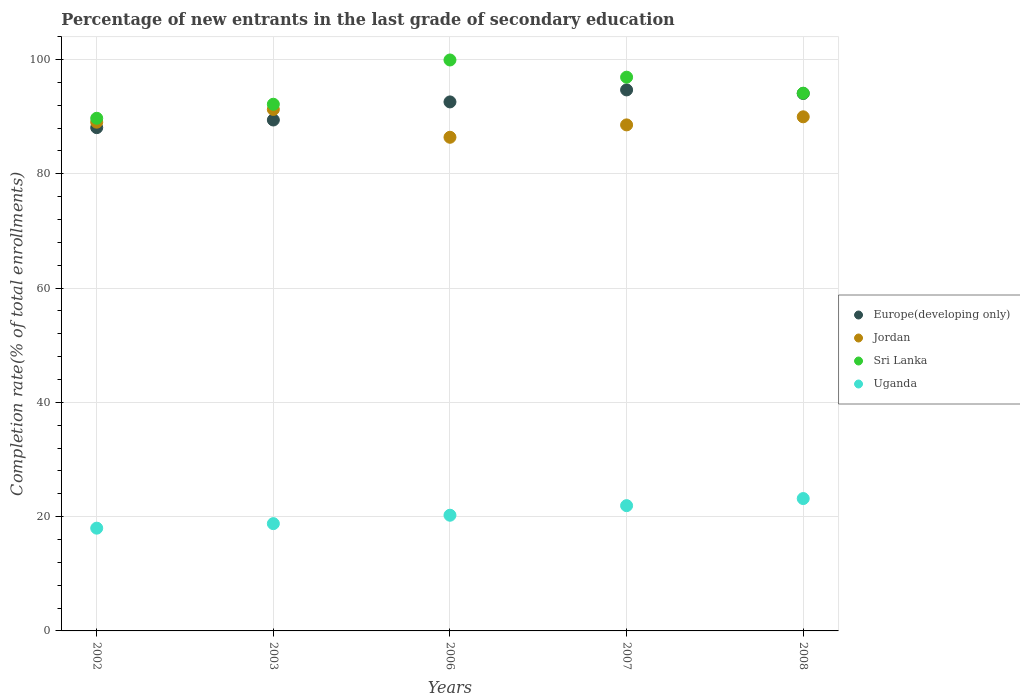What is the percentage of new entrants in Uganda in 2002?
Provide a short and direct response. 17.98. Across all years, what is the maximum percentage of new entrants in Sri Lanka?
Ensure brevity in your answer.  99.91. Across all years, what is the minimum percentage of new entrants in Sri Lanka?
Your response must be concise. 89.71. In which year was the percentage of new entrants in Jordan maximum?
Offer a terse response. 2003. In which year was the percentage of new entrants in Europe(developing only) minimum?
Provide a succinct answer. 2002. What is the total percentage of new entrants in Jordan in the graph?
Your response must be concise. 445.19. What is the difference between the percentage of new entrants in Jordan in 2003 and that in 2008?
Offer a very short reply. 1.29. What is the difference between the percentage of new entrants in Sri Lanka in 2006 and the percentage of new entrants in Europe(developing only) in 2008?
Provide a succinct answer. 5.86. What is the average percentage of new entrants in Uganda per year?
Give a very brief answer. 20.42. In the year 2007, what is the difference between the percentage of new entrants in Sri Lanka and percentage of new entrants in Jordan?
Provide a short and direct response. 8.35. What is the ratio of the percentage of new entrants in Sri Lanka in 2003 to that in 2007?
Your response must be concise. 0.95. What is the difference between the highest and the second highest percentage of new entrants in Jordan?
Your answer should be compact. 1.29. What is the difference between the highest and the lowest percentage of new entrants in Sri Lanka?
Give a very brief answer. 10.2. Is it the case that in every year, the sum of the percentage of new entrants in Jordan and percentage of new entrants in Europe(developing only)  is greater than the sum of percentage of new entrants in Sri Lanka and percentage of new entrants in Uganda?
Your answer should be very brief. No. Does the percentage of new entrants in Europe(developing only) monotonically increase over the years?
Offer a very short reply. No. Is the percentage of new entrants in Europe(developing only) strictly greater than the percentage of new entrants in Uganda over the years?
Offer a terse response. Yes. Are the values on the major ticks of Y-axis written in scientific E-notation?
Provide a short and direct response. No. Does the graph contain any zero values?
Keep it short and to the point. No. What is the title of the graph?
Ensure brevity in your answer.  Percentage of new entrants in the last grade of secondary education. Does "Serbia" appear as one of the legend labels in the graph?
Keep it short and to the point. No. What is the label or title of the Y-axis?
Your response must be concise. Completion rate(% of total enrollments). What is the Completion rate(% of total enrollments) of Europe(developing only) in 2002?
Give a very brief answer. 88.07. What is the Completion rate(% of total enrollments) in Jordan in 2002?
Keep it short and to the point. 89.03. What is the Completion rate(% of total enrollments) of Sri Lanka in 2002?
Offer a very short reply. 89.71. What is the Completion rate(% of total enrollments) of Uganda in 2002?
Offer a very short reply. 17.98. What is the Completion rate(% of total enrollments) in Europe(developing only) in 2003?
Keep it short and to the point. 89.41. What is the Completion rate(% of total enrollments) in Jordan in 2003?
Provide a succinct answer. 91.26. What is the Completion rate(% of total enrollments) in Sri Lanka in 2003?
Offer a very short reply. 92.17. What is the Completion rate(% of total enrollments) in Uganda in 2003?
Make the answer very short. 18.78. What is the Completion rate(% of total enrollments) in Europe(developing only) in 2006?
Provide a succinct answer. 92.58. What is the Completion rate(% of total enrollments) of Jordan in 2006?
Offer a very short reply. 86.39. What is the Completion rate(% of total enrollments) of Sri Lanka in 2006?
Offer a terse response. 99.91. What is the Completion rate(% of total enrollments) of Uganda in 2006?
Give a very brief answer. 20.25. What is the Completion rate(% of total enrollments) of Europe(developing only) in 2007?
Give a very brief answer. 94.68. What is the Completion rate(% of total enrollments) in Jordan in 2007?
Give a very brief answer. 88.55. What is the Completion rate(% of total enrollments) of Sri Lanka in 2007?
Give a very brief answer. 96.9. What is the Completion rate(% of total enrollments) in Uganda in 2007?
Ensure brevity in your answer.  21.92. What is the Completion rate(% of total enrollments) of Europe(developing only) in 2008?
Give a very brief answer. 94.05. What is the Completion rate(% of total enrollments) in Jordan in 2008?
Keep it short and to the point. 89.97. What is the Completion rate(% of total enrollments) in Sri Lanka in 2008?
Keep it short and to the point. 94.1. What is the Completion rate(% of total enrollments) of Uganda in 2008?
Provide a succinct answer. 23.16. Across all years, what is the maximum Completion rate(% of total enrollments) in Europe(developing only)?
Ensure brevity in your answer.  94.68. Across all years, what is the maximum Completion rate(% of total enrollments) in Jordan?
Offer a terse response. 91.26. Across all years, what is the maximum Completion rate(% of total enrollments) in Sri Lanka?
Provide a short and direct response. 99.91. Across all years, what is the maximum Completion rate(% of total enrollments) of Uganda?
Offer a terse response. 23.16. Across all years, what is the minimum Completion rate(% of total enrollments) of Europe(developing only)?
Make the answer very short. 88.07. Across all years, what is the minimum Completion rate(% of total enrollments) of Jordan?
Give a very brief answer. 86.39. Across all years, what is the minimum Completion rate(% of total enrollments) of Sri Lanka?
Your response must be concise. 89.71. Across all years, what is the minimum Completion rate(% of total enrollments) of Uganda?
Your response must be concise. 17.98. What is the total Completion rate(% of total enrollments) in Europe(developing only) in the graph?
Provide a succinct answer. 458.78. What is the total Completion rate(% of total enrollments) in Jordan in the graph?
Provide a succinct answer. 445.19. What is the total Completion rate(% of total enrollments) of Sri Lanka in the graph?
Your response must be concise. 472.8. What is the total Completion rate(% of total enrollments) in Uganda in the graph?
Ensure brevity in your answer.  102.09. What is the difference between the Completion rate(% of total enrollments) of Europe(developing only) in 2002 and that in 2003?
Provide a succinct answer. -1.34. What is the difference between the Completion rate(% of total enrollments) in Jordan in 2002 and that in 2003?
Your response must be concise. -2.23. What is the difference between the Completion rate(% of total enrollments) of Sri Lanka in 2002 and that in 2003?
Your answer should be compact. -2.45. What is the difference between the Completion rate(% of total enrollments) in Uganda in 2002 and that in 2003?
Your response must be concise. -0.79. What is the difference between the Completion rate(% of total enrollments) of Europe(developing only) in 2002 and that in 2006?
Make the answer very short. -4.5. What is the difference between the Completion rate(% of total enrollments) in Jordan in 2002 and that in 2006?
Your answer should be compact. 2.64. What is the difference between the Completion rate(% of total enrollments) in Sri Lanka in 2002 and that in 2006?
Your answer should be very brief. -10.2. What is the difference between the Completion rate(% of total enrollments) in Uganda in 2002 and that in 2006?
Your response must be concise. -2.26. What is the difference between the Completion rate(% of total enrollments) of Europe(developing only) in 2002 and that in 2007?
Offer a terse response. -6.61. What is the difference between the Completion rate(% of total enrollments) of Jordan in 2002 and that in 2007?
Make the answer very short. 0.47. What is the difference between the Completion rate(% of total enrollments) in Sri Lanka in 2002 and that in 2007?
Make the answer very short. -7.19. What is the difference between the Completion rate(% of total enrollments) in Uganda in 2002 and that in 2007?
Ensure brevity in your answer.  -3.94. What is the difference between the Completion rate(% of total enrollments) of Europe(developing only) in 2002 and that in 2008?
Your answer should be very brief. -5.98. What is the difference between the Completion rate(% of total enrollments) of Jordan in 2002 and that in 2008?
Provide a short and direct response. -0.94. What is the difference between the Completion rate(% of total enrollments) in Sri Lanka in 2002 and that in 2008?
Give a very brief answer. -4.39. What is the difference between the Completion rate(% of total enrollments) in Uganda in 2002 and that in 2008?
Provide a short and direct response. -5.18. What is the difference between the Completion rate(% of total enrollments) of Europe(developing only) in 2003 and that in 2006?
Keep it short and to the point. -3.16. What is the difference between the Completion rate(% of total enrollments) of Jordan in 2003 and that in 2006?
Offer a very short reply. 4.87. What is the difference between the Completion rate(% of total enrollments) in Sri Lanka in 2003 and that in 2006?
Keep it short and to the point. -7.75. What is the difference between the Completion rate(% of total enrollments) in Uganda in 2003 and that in 2006?
Your answer should be very brief. -1.47. What is the difference between the Completion rate(% of total enrollments) of Europe(developing only) in 2003 and that in 2007?
Your response must be concise. -5.27. What is the difference between the Completion rate(% of total enrollments) of Jordan in 2003 and that in 2007?
Offer a very short reply. 2.7. What is the difference between the Completion rate(% of total enrollments) in Sri Lanka in 2003 and that in 2007?
Give a very brief answer. -4.74. What is the difference between the Completion rate(% of total enrollments) in Uganda in 2003 and that in 2007?
Offer a very short reply. -3.15. What is the difference between the Completion rate(% of total enrollments) in Europe(developing only) in 2003 and that in 2008?
Your answer should be compact. -4.64. What is the difference between the Completion rate(% of total enrollments) of Jordan in 2003 and that in 2008?
Provide a short and direct response. 1.29. What is the difference between the Completion rate(% of total enrollments) of Sri Lanka in 2003 and that in 2008?
Your answer should be very brief. -1.93. What is the difference between the Completion rate(% of total enrollments) of Uganda in 2003 and that in 2008?
Make the answer very short. -4.39. What is the difference between the Completion rate(% of total enrollments) in Europe(developing only) in 2006 and that in 2007?
Offer a very short reply. -2.1. What is the difference between the Completion rate(% of total enrollments) of Jordan in 2006 and that in 2007?
Your answer should be compact. -2.17. What is the difference between the Completion rate(% of total enrollments) in Sri Lanka in 2006 and that in 2007?
Provide a short and direct response. 3.01. What is the difference between the Completion rate(% of total enrollments) of Uganda in 2006 and that in 2007?
Provide a succinct answer. -1.68. What is the difference between the Completion rate(% of total enrollments) in Europe(developing only) in 2006 and that in 2008?
Keep it short and to the point. -1.48. What is the difference between the Completion rate(% of total enrollments) of Jordan in 2006 and that in 2008?
Your response must be concise. -3.58. What is the difference between the Completion rate(% of total enrollments) in Sri Lanka in 2006 and that in 2008?
Provide a succinct answer. 5.81. What is the difference between the Completion rate(% of total enrollments) in Uganda in 2006 and that in 2008?
Your answer should be very brief. -2.92. What is the difference between the Completion rate(% of total enrollments) in Europe(developing only) in 2007 and that in 2008?
Provide a short and direct response. 0.62. What is the difference between the Completion rate(% of total enrollments) in Jordan in 2007 and that in 2008?
Offer a very short reply. -1.41. What is the difference between the Completion rate(% of total enrollments) in Sri Lanka in 2007 and that in 2008?
Give a very brief answer. 2.8. What is the difference between the Completion rate(% of total enrollments) in Uganda in 2007 and that in 2008?
Keep it short and to the point. -1.24. What is the difference between the Completion rate(% of total enrollments) in Europe(developing only) in 2002 and the Completion rate(% of total enrollments) in Jordan in 2003?
Provide a succinct answer. -3.19. What is the difference between the Completion rate(% of total enrollments) in Europe(developing only) in 2002 and the Completion rate(% of total enrollments) in Sri Lanka in 2003?
Provide a succinct answer. -4.1. What is the difference between the Completion rate(% of total enrollments) in Europe(developing only) in 2002 and the Completion rate(% of total enrollments) in Uganda in 2003?
Give a very brief answer. 69.29. What is the difference between the Completion rate(% of total enrollments) in Jordan in 2002 and the Completion rate(% of total enrollments) in Sri Lanka in 2003?
Your answer should be very brief. -3.14. What is the difference between the Completion rate(% of total enrollments) of Jordan in 2002 and the Completion rate(% of total enrollments) of Uganda in 2003?
Offer a very short reply. 70.25. What is the difference between the Completion rate(% of total enrollments) of Sri Lanka in 2002 and the Completion rate(% of total enrollments) of Uganda in 2003?
Ensure brevity in your answer.  70.94. What is the difference between the Completion rate(% of total enrollments) of Europe(developing only) in 2002 and the Completion rate(% of total enrollments) of Jordan in 2006?
Ensure brevity in your answer.  1.68. What is the difference between the Completion rate(% of total enrollments) of Europe(developing only) in 2002 and the Completion rate(% of total enrollments) of Sri Lanka in 2006?
Keep it short and to the point. -11.84. What is the difference between the Completion rate(% of total enrollments) in Europe(developing only) in 2002 and the Completion rate(% of total enrollments) in Uganda in 2006?
Offer a very short reply. 67.82. What is the difference between the Completion rate(% of total enrollments) in Jordan in 2002 and the Completion rate(% of total enrollments) in Sri Lanka in 2006?
Provide a short and direct response. -10.89. What is the difference between the Completion rate(% of total enrollments) of Jordan in 2002 and the Completion rate(% of total enrollments) of Uganda in 2006?
Provide a succinct answer. 68.78. What is the difference between the Completion rate(% of total enrollments) in Sri Lanka in 2002 and the Completion rate(% of total enrollments) in Uganda in 2006?
Your response must be concise. 69.47. What is the difference between the Completion rate(% of total enrollments) in Europe(developing only) in 2002 and the Completion rate(% of total enrollments) in Jordan in 2007?
Give a very brief answer. -0.48. What is the difference between the Completion rate(% of total enrollments) in Europe(developing only) in 2002 and the Completion rate(% of total enrollments) in Sri Lanka in 2007?
Give a very brief answer. -8.83. What is the difference between the Completion rate(% of total enrollments) of Europe(developing only) in 2002 and the Completion rate(% of total enrollments) of Uganda in 2007?
Your answer should be compact. 66.15. What is the difference between the Completion rate(% of total enrollments) of Jordan in 2002 and the Completion rate(% of total enrollments) of Sri Lanka in 2007?
Provide a short and direct response. -7.87. What is the difference between the Completion rate(% of total enrollments) of Jordan in 2002 and the Completion rate(% of total enrollments) of Uganda in 2007?
Offer a terse response. 67.11. What is the difference between the Completion rate(% of total enrollments) of Sri Lanka in 2002 and the Completion rate(% of total enrollments) of Uganda in 2007?
Provide a short and direct response. 67.79. What is the difference between the Completion rate(% of total enrollments) in Europe(developing only) in 2002 and the Completion rate(% of total enrollments) in Jordan in 2008?
Provide a short and direct response. -1.9. What is the difference between the Completion rate(% of total enrollments) in Europe(developing only) in 2002 and the Completion rate(% of total enrollments) in Sri Lanka in 2008?
Offer a very short reply. -6.03. What is the difference between the Completion rate(% of total enrollments) of Europe(developing only) in 2002 and the Completion rate(% of total enrollments) of Uganda in 2008?
Ensure brevity in your answer.  64.91. What is the difference between the Completion rate(% of total enrollments) of Jordan in 2002 and the Completion rate(% of total enrollments) of Sri Lanka in 2008?
Offer a very short reply. -5.07. What is the difference between the Completion rate(% of total enrollments) in Jordan in 2002 and the Completion rate(% of total enrollments) in Uganda in 2008?
Give a very brief answer. 65.86. What is the difference between the Completion rate(% of total enrollments) of Sri Lanka in 2002 and the Completion rate(% of total enrollments) of Uganda in 2008?
Your answer should be very brief. 66.55. What is the difference between the Completion rate(% of total enrollments) of Europe(developing only) in 2003 and the Completion rate(% of total enrollments) of Jordan in 2006?
Keep it short and to the point. 3.02. What is the difference between the Completion rate(% of total enrollments) in Europe(developing only) in 2003 and the Completion rate(% of total enrollments) in Sri Lanka in 2006?
Provide a succinct answer. -10.5. What is the difference between the Completion rate(% of total enrollments) of Europe(developing only) in 2003 and the Completion rate(% of total enrollments) of Uganda in 2006?
Provide a succinct answer. 69.16. What is the difference between the Completion rate(% of total enrollments) of Jordan in 2003 and the Completion rate(% of total enrollments) of Sri Lanka in 2006?
Offer a very short reply. -8.66. What is the difference between the Completion rate(% of total enrollments) of Jordan in 2003 and the Completion rate(% of total enrollments) of Uganda in 2006?
Your response must be concise. 71.01. What is the difference between the Completion rate(% of total enrollments) of Sri Lanka in 2003 and the Completion rate(% of total enrollments) of Uganda in 2006?
Offer a terse response. 71.92. What is the difference between the Completion rate(% of total enrollments) of Europe(developing only) in 2003 and the Completion rate(% of total enrollments) of Jordan in 2007?
Make the answer very short. 0.86. What is the difference between the Completion rate(% of total enrollments) in Europe(developing only) in 2003 and the Completion rate(% of total enrollments) in Sri Lanka in 2007?
Offer a terse response. -7.49. What is the difference between the Completion rate(% of total enrollments) of Europe(developing only) in 2003 and the Completion rate(% of total enrollments) of Uganda in 2007?
Ensure brevity in your answer.  67.49. What is the difference between the Completion rate(% of total enrollments) in Jordan in 2003 and the Completion rate(% of total enrollments) in Sri Lanka in 2007?
Offer a terse response. -5.65. What is the difference between the Completion rate(% of total enrollments) in Jordan in 2003 and the Completion rate(% of total enrollments) in Uganda in 2007?
Ensure brevity in your answer.  69.33. What is the difference between the Completion rate(% of total enrollments) in Sri Lanka in 2003 and the Completion rate(% of total enrollments) in Uganda in 2007?
Offer a very short reply. 70.24. What is the difference between the Completion rate(% of total enrollments) in Europe(developing only) in 2003 and the Completion rate(% of total enrollments) in Jordan in 2008?
Give a very brief answer. -0.56. What is the difference between the Completion rate(% of total enrollments) in Europe(developing only) in 2003 and the Completion rate(% of total enrollments) in Sri Lanka in 2008?
Give a very brief answer. -4.69. What is the difference between the Completion rate(% of total enrollments) in Europe(developing only) in 2003 and the Completion rate(% of total enrollments) in Uganda in 2008?
Keep it short and to the point. 66.25. What is the difference between the Completion rate(% of total enrollments) in Jordan in 2003 and the Completion rate(% of total enrollments) in Sri Lanka in 2008?
Ensure brevity in your answer.  -2.84. What is the difference between the Completion rate(% of total enrollments) in Jordan in 2003 and the Completion rate(% of total enrollments) in Uganda in 2008?
Provide a short and direct response. 68.09. What is the difference between the Completion rate(% of total enrollments) in Sri Lanka in 2003 and the Completion rate(% of total enrollments) in Uganda in 2008?
Your answer should be compact. 69. What is the difference between the Completion rate(% of total enrollments) in Europe(developing only) in 2006 and the Completion rate(% of total enrollments) in Jordan in 2007?
Your answer should be compact. 4.02. What is the difference between the Completion rate(% of total enrollments) in Europe(developing only) in 2006 and the Completion rate(% of total enrollments) in Sri Lanka in 2007?
Your answer should be very brief. -4.33. What is the difference between the Completion rate(% of total enrollments) in Europe(developing only) in 2006 and the Completion rate(% of total enrollments) in Uganda in 2007?
Your answer should be very brief. 70.65. What is the difference between the Completion rate(% of total enrollments) of Jordan in 2006 and the Completion rate(% of total enrollments) of Sri Lanka in 2007?
Your answer should be compact. -10.52. What is the difference between the Completion rate(% of total enrollments) in Jordan in 2006 and the Completion rate(% of total enrollments) in Uganda in 2007?
Offer a terse response. 64.46. What is the difference between the Completion rate(% of total enrollments) of Sri Lanka in 2006 and the Completion rate(% of total enrollments) of Uganda in 2007?
Your response must be concise. 77.99. What is the difference between the Completion rate(% of total enrollments) of Europe(developing only) in 2006 and the Completion rate(% of total enrollments) of Jordan in 2008?
Make the answer very short. 2.61. What is the difference between the Completion rate(% of total enrollments) in Europe(developing only) in 2006 and the Completion rate(% of total enrollments) in Sri Lanka in 2008?
Your response must be concise. -1.53. What is the difference between the Completion rate(% of total enrollments) in Europe(developing only) in 2006 and the Completion rate(% of total enrollments) in Uganda in 2008?
Provide a succinct answer. 69.41. What is the difference between the Completion rate(% of total enrollments) of Jordan in 2006 and the Completion rate(% of total enrollments) of Sri Lanka in 2008?
Your answer should be very brief. -7.71. What is the difference between the Completion rate(% of total enrollments) in Jordan in 2006 and the Completion rate(% of total enrollments) in Uganda in 2008?
Keep it short and to the point. 63.22. What is the difference between the Completion rate(% of total enrollments) in Sri Lanka in 2006 and the Completion rate(% of total enrollments) in Uganda in 2008?
Provide a short and direct response. 76.75. What is the difference between the Completion rate(% of total enrollments) in Europe(developing only) in 2007 and the Completion rate(% of total enrollments) in Jordan in 2008?
Make the answer very short. 4.71. What is the difference between the Completion rate(% of total enrollments) in Europe(developing only) in 2007 and the Completion rate(% of total enrollments) in Sri Lanka in 2008?
Provide a succinct answer. 0.58. What is the difference between the Completion rate(% of total enrollments) in Europe(developing only) in 2007 and the Completion rate(% of total enrollments) in Uganda in 2008?
Offer a very short reply. 71.51. What is the difference between the Completion rate(% of total enrollments) in Jordan in 2007 and the Completion rate(% of total enrollments) in Sri Lanka in 2008?
Provide a succinct answer. -5.55. What is the difference between the Completion rate(% of total enrollments) in Jordan in 2007 and the Completion rate(% of total enrollments) in Uganda in 2008?
Offer a terse response. 65.39. What is the difference between the Completion rate(% of total enrollments) of Sri Lanka in 2007 and the Completion rate(% of total enrollments) of Uganda in 2008?
Offer a terse response. 73.74. What is the average Completion rate(% of total enrollments) in Europe(developing only) per year?
Your answer should be compact. 91.76. What is the average Completion rate(% of total enrollments) of Jordan per year?
Your response must be concise. 89.04. What is the average Completion rate(% of total enrollments) in Sri Lanka per year?
Your response must be concise. 94.56. What is the average Completion rate(% of total enrollments) of Uganda per year?
Offer a very short reply. 20.42. In the year 2002, what is the difference between the Completion rate(% of total enrollments) in Europe(developing only) and Completion rate(% of total enrollments) in Jordan?
Keep it short and to the point. -0.96. In the year 2002, what is the difference between the Completion rate(% of total enrollments) in Europe(developing only) and Completion rate(% of total enrollments) in Sri Lanka?
Offer a terse response. -1.64. In the year 2002, what is the difference between the Completion rate(% of total enrollments) of Europe(developing only) and Completion rate(% of total enrollments) of Uganda?
Make the answer very short. 70.09. In the year 2002, what is the difference between the Completion rate(% of total enrollments) of Jordan and Completion rate(% of total enrollments) of Sri Lanka?
Make the answer very short. -0.69. In the year 2002, what is the difference between the Completion rate(% of total enrollments) in Jordan and Completion rate(% of total enrollments) in Uganda?
Provide a succinct answer. 71.04. In the year 2002, what is the difference between the Completion rate(% of total enrollments) of Sri Lanka and Completion rate(% of total enrollments) of Uganda?
Ensure brevity in your answer.  71.73. In the year 2003, what is the difference between the Completion rate(% of total enrollments) in Europe(developing only) and Completion rate(% of total enrollments) in Jordan?
Provide a succinct answer. -1.85. In the year 2003, what is the difference between the Completion rate(% of total enrollments) of Europe(developing only) and Completion rate(% of total enrollments) of Sri Lanka?
Offer a very short reply. -2.76. In the year 2003, what is the difference between the Completion rate(% of total enrollments) of Europe(developing only) and Completion rate(% of total enrollments) of Uganda?
Provide a succinct answer. 70.63. In the year 2003, what is the difference between the Completion rate(% of total enrollments) in Jordan and Completion rate(% of total enrollments) in Sri Lanka?
Offer a very short reply. -0.91. In the year 2003, what is the difference between the Completion rate(% of total enrollments) in Jordan and Completion rate(% of total enrollments) in Uganda?
Give a very brief answer. 72.48. In the year 2003, what is the difference between the Completion rate(% of total enrollments) of Sri Lanka and Completion rate(% of total enrollments) of Uganda?
Keep it short and to the point. 73.39. In the year 2006, what is the difference between the Completion rate(% of total enrollments) in Europe(developing only) and Completion rate(% of total enrollments) in Jordan?
Provide a short and direct response. 6.19. In the year 2006, what is the difference between the Completion rate(% of total enrollments) in Europe(developing only) and Completion rate(% of total enrollments) in Sri Lanka?
Your response must be concise. -7.34. In the year 2006, what is the difference between the Completion rate(% of total enrollments) of Europe(developing only) and Completion rate(% of total enrollments) of Uganda?
Give a very brief answer. 72.33. In the year 2006, what is the difference between the Completion rate(% of total enrollments) in Jordan and Completion rate(% of total enrollments) in Sri Lanka?
Provide a succinct answer. -13.53. In the year 2006, what is the difference between the Completion rate(% of total enrollments) of Jordan and Completion rate(% of total enrollments) of Uganda?
Give a very brief answer. 66.14. In the year 2006, what is the difference between the Completion rate(% of total enrollments) in Sri Lanka and Completion rate(% of total enrollments) in Uganda?
Keep it short and to the point. 79.67. In the year 2007, what is the difference between the Completion rate(% of total enrollments) of Europe(developing only) and Completion rate(% of total enrollments) of Jordan?
Provide a short and direct response. 6.12. In the year 2007, what is the difference between the Completion rate(% of total enrollments) in Europe(developing only) and Completion rate(% of total enrollments) in Sri Lanka?
Keep it short and to the point. -2.23. In the year 2007, what is the difference between the Completion rate(% of total enrollments) in Europe(developing only) and Completion rate(% of total enrollments) in Uganda?
Offer a terse response. 72.75. In the year 2007, what is the difference between the Completion rate(% of total enrollments) of Jordan and Completion rate(% of total enrollments) of Sri Lanka?
Keep it short and to the point. -8.35. In the year 2007, what is the difference between the Completion rate(% of total enrollments) of Jordan and Completion rate(% of total enrollments) of Uganda?
Ensure brevity in your answer.  66.63. In the year 2007, what is the difference between the Completion rate(% of total enrollments) in Sri Lanka and Completion rate(% of total enrollments) in Uganda?
Make the answer very short. 74.98. In the year 2008, what is the difference between the Completion rate(% of total enrollments) in Europe(developing only) and Completion rate(% of total enrollments) in Jordan?
Make the answer very short. 4.08. In the year 2008, what is the difference between the Completion rate(% of total enrollments) of Europe(developing only) and Completion rate(% of total enrollments) of Sri Lanka?
Your answer should be very brief. -0.05. In the year 2008, what is the difference between the Completion rate(% of total enrollments) of Europe(developing only) and Completion rate(% of total enrollments) of Uganda?
Give a very brief answer. 70.89. In the year 2008, what is the difference between the Completion rate(% of total enrollments) in Jordan and Completion rate(% of total enrollments) in Sri Lanka?
Your response must be concise. -4.13. In the year 2008, what is the difference between the Completion rate(% of total enrollments) in Jordan and Completion rate(% of total enrollments) in Uganda?
Provide a succinct answer. 66.8. In the year 2008, what is the difference between the Completion rate(% of total enrollments) in Sri Lanka and Completion rate(% of total enrollments) in Uganda?
Offer a terse response. 70.94. What is the ratio of the Completion rate(% of total enrollments) of Jordan in 2002 to that in 2003?
Ensure brevity in your answer.  0.98. What is the ratio of the Completion rate(% of total enrollments) of Sri Lanka in 2002 to that in 2003?
Make the answer very short. 0.97. What is the ratio of the Completion rate(% of total enrollments) in Uganda in 2002 to that in 2003?
Keep it short and to the point. 0.96. What is the ratio of the Completion rate(% of total enrollments) in Europe(developing only) in 2002 to that in 2006?
Your answer should be compact. 0.95. What is the ratio of the Completion rate(% of total enrollments) of Jordan in 2002 to that in 2006?
Your answer should be very brief. 1.03. What is the ratio of the Completion rate(% of total enrollments) in Sri Lanka in 2002 to that in 2006?
Your response must be concise. 0.9. What is the ratio of the Completion rate(% of total enrollments) in Uganda in 2002 to that in 2006?
Ensure brevity in your answer.  0.89. What is the ratio of the Completion rate(% of total enrollments) in Europe(developing only) in 2002 to that in 2007?
Your answer should be very brief. 0.93. What is the ratio of the Completion rate(% of total enrollments) in Sri Lanka in 2002 to that in 2007?
Provide a short and direct response. 0.93. What is the ratio of the Completion rate(% of total enrollments) in Uganda in 2002 to that in 2007?
Give a very brief answer. 0.82. What is the ratio of the Completion rate(% of total enrollments) in Europe(developing only) in 2002 to that in 2008?
Give a very brief answer. 0.94. What is the ratio of the Completion rate(% of total enrollments) of Jordan in 2002 to that in 2008?
Give a very brief answer. 0.99. What is the ratio of the Completion rate(% of total enrollments) of Sri Lanka in 2002 to that in 2008?
Offer a terse response. 0.95. What is the ratio of the Completion rate(% of total enrollments) of Uganda in 2002 to that in 2008?
Keep it short and to the point. 0.78. What is the ratio of the Completion rate(% of total enrollments) in Europe(developing only) in 2003 to that in 2006?
Offer a terse response. 0.97. What is the ratio of the Completion rate(% of total enrollments) in Jordan in 2003 to that in 2006?
Your answer should be compact. 1.06. What is the ratio of the Completion rate(% of total enrollments) of Sri Lanka in 2003 to that in 2006?
Your answer should be very brief. 0.92. What is the ratio of the Completion rate(% of total enrollments) of Uganda in 2003 to that in 2006?
Ensure brevity in your answer.  0.93. What is the ratio of the Completion rate(% of total enrollments) in Jordan in 2003 to that in 2007?
Provide a short and direct response. 1.03. What is the ratio of the Completion rate(% of total enrollments) in Sri Lanka in 2003 to that in 2007?
Your response must be concise. 0.95. What is the ratio of the Completion rate(% of total enrollments) in Uganda in 2003 to that in 2007?
Provide a succinct answer. 0.86. What is the ratio of the Completion rate(% of total enrollments) of Europe(developing only) in 2003 to that in 2008?
Your response must be concise. 0.95. What is the ratio of the Completion rate(% of total enrollments) in Jordan in 2003 to that in 2008?
Keep it short and to the point. 1.01. What is the ratio of the Completion rate(% of total enrollments) of Sri Lanka in 2003 to that in 2008?
Your answer should be compact. 0.98. What is the ratio of the Completion rate(% of total enrollments) of Uganda in 2003 to that in 2008?
Offer a very short reply. 0.81. What is the ratio of the Completion rate(% of total enrollments) of Europe(developing only) in 2006 to that in 2007?
Provide a short and direct response. 0.98. What is the ratio of the Completion rate(% of total enrollments) of Jordan in 2006 to that in 2007?
Your answer should be compact. 0.98. What is the ratio of the Completion rate(% of total enrollments) in Sri Lanka in 2006 to that in 2007?
Your answer should be very brief. 1.03. What is the ratio of the Completion rate(% of total enrollments) in Uganda in 2006 to that in 2007?
Offer a very short reply. 0.92. What is the ratio of the Completion rate(% of total enrollments) in Europe(developing only) in 2006 to that in 2008?
Provide a succinct answer. 0.98. What is the ratio of the Completion rate(% of total enrollments) of Jordan in 2006 to that in 2008?
Ensure brevity in your answer.  0.96. What is the ratio of the Completion rate(% of total enrollments) of Sri Lanka in 2006 to that in 2008?
Your answer should be compact. 1.06. What is the ratio of the Completion rate(% of total enrollments) in Uganda in 2006 to that in 2008?
Ensure brevity in your answer.  0.87. What is the ratio of the Completion rate(% of total enrollments) in Europe(developing only) in 2007 to that in 2008?
Give a very brief answer. 1.01. What is the ratio of the Completion rate(% of total enrollments) in Jordan in 2007 to that in 2008?
Give a very brief answer. 0.98. What is the ratio of the Completion rate(% of total enrollments) in Sri Lanka in 2007 to that in 2008?
Ensure brevity in your answer.  1.03. What is the ratio of the Completion rate(% of total enrollments) of Uganda in 2007 to that in 2008?
Keep it short and to the point. 0.95. What is the difference between the highest and the second highest Completion rate(% of total enrollments) of Europe(developing only)?
Keep it short and to the point. 0.62. What is the difference between the highest and the second highest Completion rate(% of total enrollments) of Jordan?
Offer a terse response. 1.29. What is the difference between the highest and the second highest Completion rate(% of total enrollments) of Sri Lanka?
Your response must be concise. 3.01. What is the difference between the highest and the second highest Completion rate(% of total enrollments) in Uganda?
Ensure brevity in your answer.  1.24. What is the difference between the highest and the lowest Completion rate(% of total enrollments) in Europe(developing only)?
Give a very brief answer. 6.61. What is the difference between the highest and the lowest Completion rate(% of total enrollments) of Jordan?
Offer a very short reply. 4.87. What is the difference between the highest and the lowest Completion rate(% of total enrollments) in Sri Lanka?
Offer a very short reply. 10.2. What is the difference between the highest and the lowest Completion rate(% of total enrollments) of Uganda?
Provide a short and direct response. 5.18. 